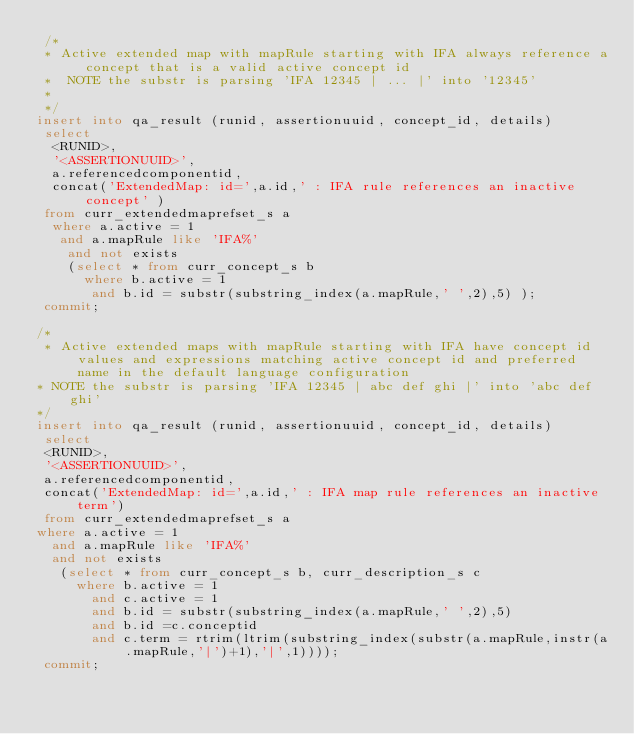<code> <loc_0><loc_0><loc_500><loc_500><_SQL_> /*
 * Active extended map with mapRule starting with IFA always reference a concept that is a valid active concept id
 *  NOTE the substr is parsing 'IFA 12345 | ... |' into '12345'
 *
 */
insert into qa_result (runid, assertionuuid, concept_id, details)
 select
 	<RUNID>,
 	'<ASSERTIONUUID>',
 	a.referencedcomponentid,
 	concat('ExtendedMap: id=',a.id,' : IFA rule references an inactive concept' )  
 from curr_extendedmaprefset_s a
	where a.active = 1
 	 and a.mapRule like 'IFA%'
  	and not exists
    (select * from curr_concept_s b
     	where b.active = 1
       and b.id = substr(substring_index(a.mapRule,' ',2),5) );
 commit;
 
/*
 * Active extended maps with mapRule starting with IFA have concept id values and expressions matching active concept id and preferred name in the default language configuration
* NOTE the substr is parsing 'IFA 12345 | abc def ghi |' into 'abc def ghi'
*/ 
insert into qa_result (runid, assertionuuid, concept_id, details)
 select
 <RUNID>,
 '<ASSERTIONUUID>',
 a.referencedcomponentid,
 concat('ExtendedMap: id=',a.id,' : IFA map rule references an inactive term')       
 from curr_extendedmaprefset_s a
where a.active = 1
  and a.mapRule like 'IFA%'
  and not exists
   (select * from curr_concept_s b, curr_description_s c
     where b.active = 1
       and c.active = 1
       and b.id = substr(substring_index(a.mapRule,' ',2),5)
       and b.id =c.conceptid
       and c.term = rtrim(ltrim(substring_index(substr(a.mapRule,instr(a.mapRule,'|')+1),'|',1))));
 commit;
 </code> 